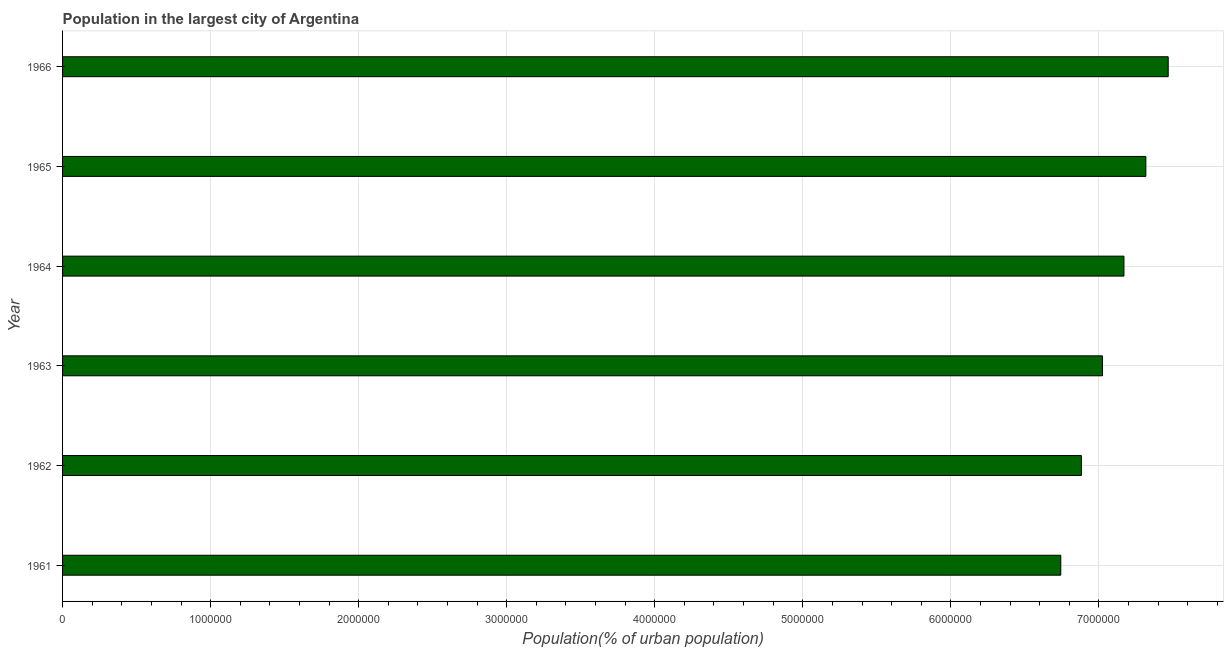Does the graph contain any zero values?
Provide a short and direct response. No. What is the title of the graph?
Provide a succinct answer. Population in the largest city of Argentina. What is the label or title of the X-axis?
Offer a terse response. Population(% of urban population). What is the label or title of the Y-axis?
Your response must be concise. Year. What is the population in largest city in 1961?
Offer a very short reply. 6.74e+06. Across all years, what is the maximum population in largest city?
Ensure brevity in your answer.  7.47e+06. Across all years, what is the minimum population in largest city?
Provide a succinct answer. 6.74e+06. In which year was the population in largest city maximum?
Provide a short and direct response. 1966. In which year was the population in largest city minimum?
Offer a very short reply. 1961. What is the sum of the population in largest city?
Make the answer very short. 4.26e+07. What is the difference between the population in largest city in 1963 and 1965?
Offer a terse response. -2.93e+05. What is the average population in largest city per year?
Keep it short and to the point. 7.10e+06. What is the median population in largest city?
Your response must be concise. 7.10e+06. In how many years, is the population in largest city greater than 1400000 %?
Ensure brevity in your answer.  6. What is the ratio of the population in largest city in 1963 to that in 1965?
Offer a very short reply. 0.96. Is the population in largest city in 1963 less than that in 1964?
Keep it short and to the point. Yes. What is the difference between the highest and the second highest population in largest city?
Provide a short and direct response. 1.51e+05. Is the sum of the population in largest city in 1961 and 1965 greater than the maximum population in largest city across all years?
Your answer should be very brief. Yes. What is the difference between the highest and the lowest population in largest city?
Ensure brevity in your answer.  7.26e+05. How many bars are there?
Provide a short and direct response. 6. Are all the bars in the graph horizontal?
Your answer should be compact. Yes. How many years are there in the graph?
Keep it short and to the point. 6. Are the values on the major ticks of X-axis written in scientific E-notation?
Provide a short and direct response. No. What is the Population(% of urban population) in 1961?
Offer a terse response. 6.74e+06. What is the Population(% of urban population) of 1962?
Offer a terse response. 6.88e+06. What is the Population(% of urban population) in 1963?
Ensure brevity in your answer.  7.02e+06. What is the Population(% of urban population) in 1964?
Provide a short and direct response. 7.17e+06. What is the Population(% of urban population) of 1965?
Your answer should be very brief. 7.32e+06. What is the Population(% of urban population) of 1966?
Provide a succinct answer. 7.47e+06. What is the difference between the Population(% of urban population) in 1961 and 1962?
Keep it short and to the point. -1.39e+05. What is the difference between the Population(% of urban population) in 1961 and 1963?
Offer a very short reply. -2.81e+05. What is the difference between the Population(% of urban population) in 1961 and 1964?
Offer a terse response. -4.27e+05. What is the difference between the Population(% of urban population) in 1961 and 1965?
Your answer should be very brief. -5.75e+05. What is the difference between the Population(% of urban population) in 1961 and 1966?
Provide a succinct answer. -7.26e+05. What is the difference between the Population(% of urban population) in 1962 and 1963?
Your answer should be compact. -1.42e+05. What is the difference between the Population(% of urban population) in 1962 and 1964?
Your response must be concise. -2.87e+05. What is the difference between the Population(% of urban population) in 1962 and 1965?
Give a very brief answer. -4.35e+05. What is the difference between the Population(% of urban population) in 1962 and 1966?
Provide a short and direct response. -5.86e+05. What is the difference between the Population(% of urban population) in 1963 and 1964?
Offer a very short reply. -1.45e+05. What is the difference between the Population(% of urban population) in 1963 and 1965?
Keep it short and to the point. -2.93e+05. What is the difference between the Population(% of urban population) in 1963 and 1966?
Your answer should be compact. -4.44e+05. What is the difference between the Population(% of urban population) in 1964 and 1965?
Your answer should be very brief. -1.48e+05. What is the difference between the Population(% of urban population) in 1964 and 1966?
Provide a short and direct response. -2.99e+05. What is the difference between the Population(% of urban population) in 1965 and 1966?
Provide a short and direct response. -1.51e+05. What is the ratio of the Population(% of urban population) in 1961 to that in 1963?
Make the answer very short. 0.96. What is the ratio of the Population(% of urban population) in 1961 to that in 1965?
Ensure brevity in your answer.  0.92. What is the ratio of the Population(% of urban population) in 1961 to that in 1966?
Ensure brevity in your answer.  0.9. What is the ratio of the Population(% of urban population) in 1962 to that in 1965?
Make the answer very short. 0.94. What is the ratio of the Population(% of urban population) in 1962 to that in 1966?
Keep it short and to the point. 0.92. What is the ratio of the Population(% of urban population) in 1963 to that in 1965?
Keep it short and to the point. 0.96. What is the ratio of the Population(% of urban population) in 1963 to that in 1966?
Your answer should be very brief. 0.94. What is the ratio of the Population(% of urban population) in 1964 to that in 1966?
Provide a short and direct response. 0.96. What is the ratio of the Population(% of urban population) in 1965 to that in 1966?
Ensure brevity in your answer.  0.98. 